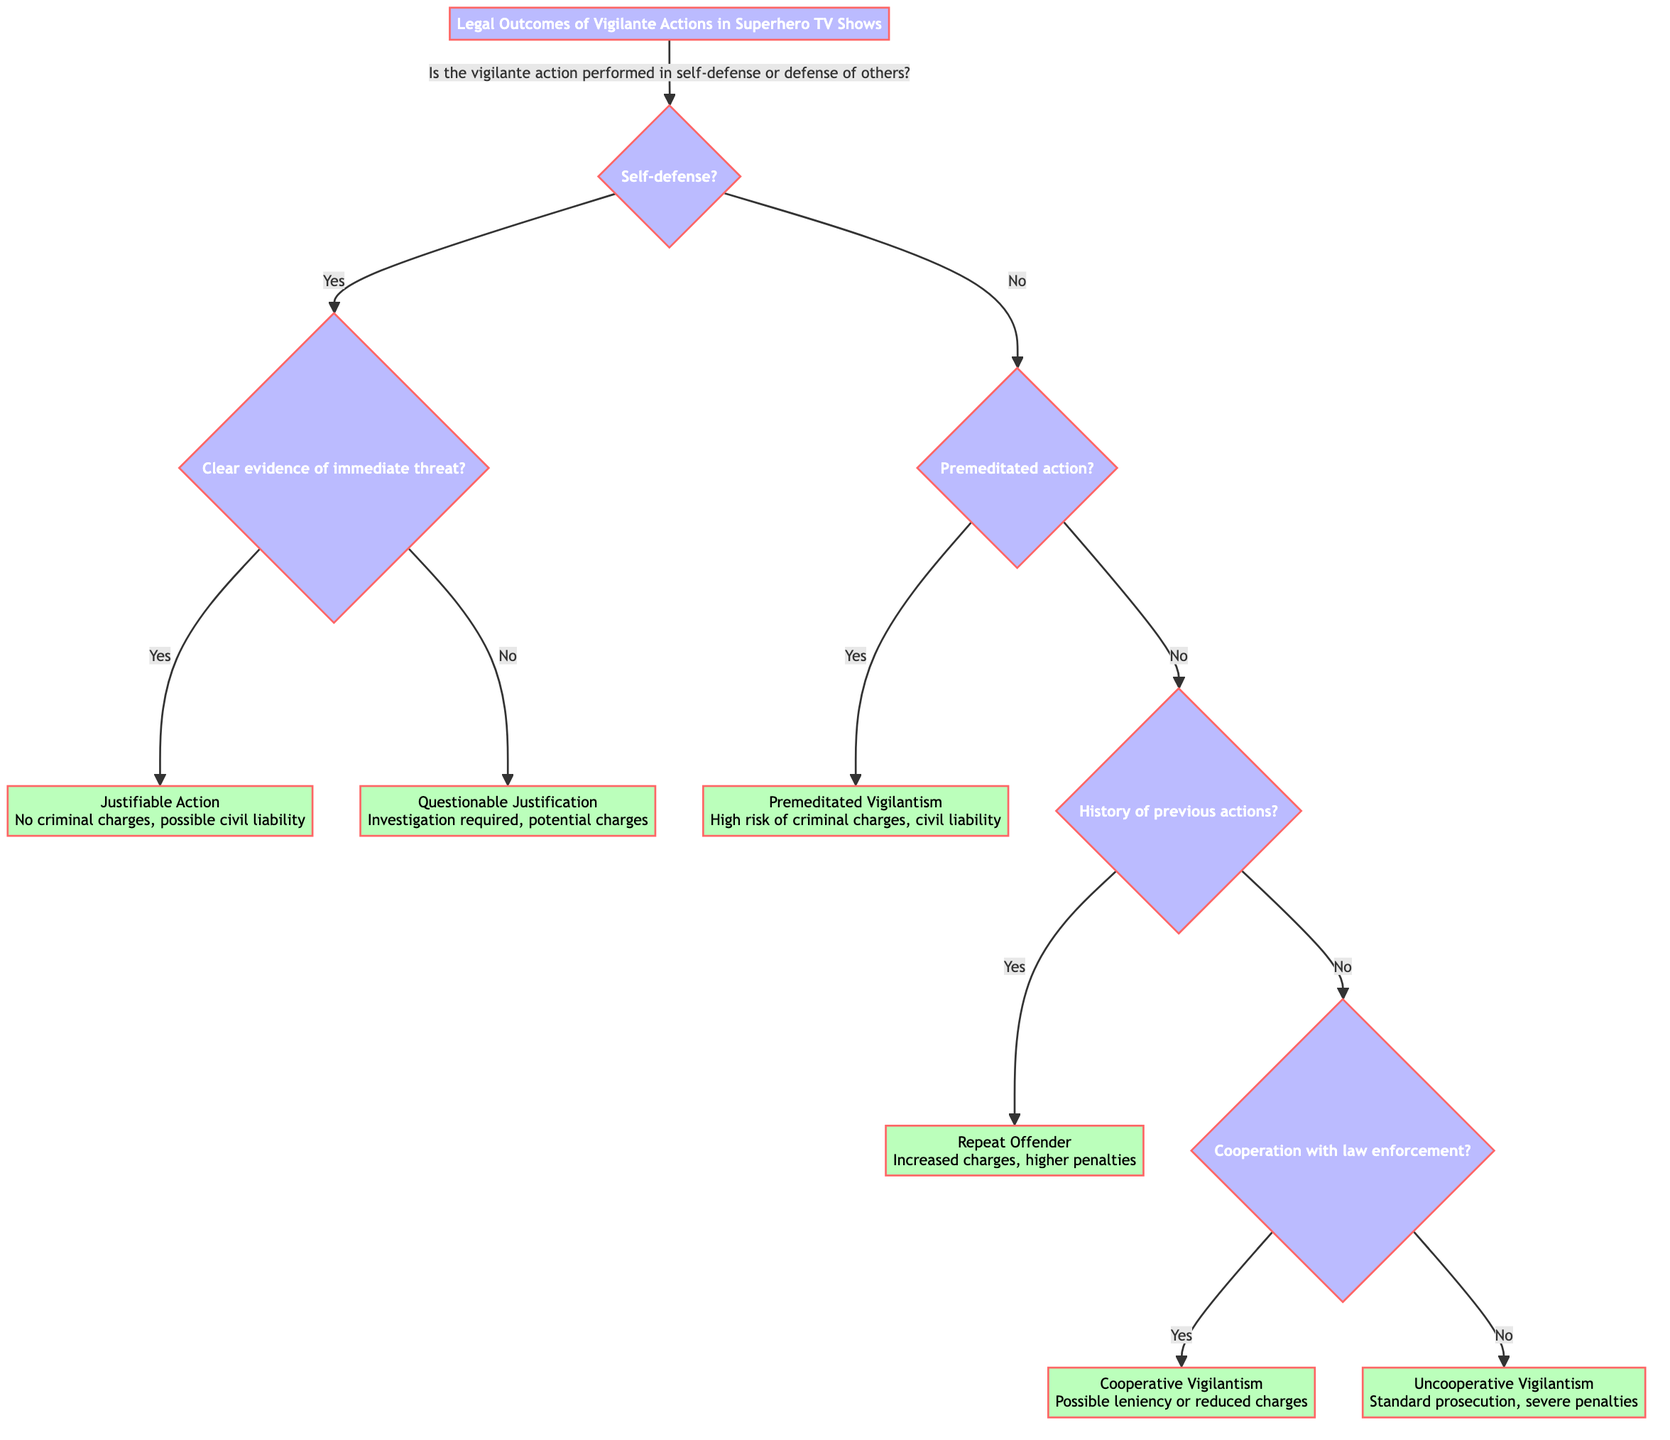Is the first decision about self-defense? Yes, the first decision node specifically asks if the vigilante action is performed in self-defense or defense of others.
Answer: Yes What is the outcome if there is clear evidence of an immediate threat? If there is clear evidence of an immediate threat, the next outcome node indicates that the action is considered "Justifiable Action," with no criminal charges and possible civil liability.
Answer: Justifiable Action How many outcomes follow the decision of premeditation? Following the decision of premeditated action, there are two possible outcomes: "Premeditated Vigilantism" and the other branches regarding the history of previous actions.
Answer: Two What happens if a vigilante has a history of previous actions? If there is a history of previous vigilante actions, the outcome is classified as "Repeat Offender," which indicates increased criminal charges and the possibility of higher penalties.
Answer: Repeat Offender What is the legal response for "Cooperative Vigilantism"? The legal response outlined for "Cooperative Vigilantism" describes the possibility of leniency or reduced charges based on jurisdiction and circumstances surrounding the case.
Answer: Possible leniency or reduced charges What is the outcome if the vigilante action is uncooperative? According to the diagram, if the vigilante action is categorized as uncooperative, the outcome noted is "Uncooperative Vigilantism," subjected to standard prosecution procedures and the potential for severe penalties.
Answer: Uncooperative Vigilantism Is there a decision regarding cooperation with law enforcement? Yes, there is a specific decision node that asks whether there was cooperation with law enforcement, which determines the outcome path taken next.
Answer: Yes What is the outcome for an action deemed as "Questionable Justification"? The outcome for "Questionable Justification" indicates that an investigation is required, which may result in potential criminal charges or civil liability.
Answer: Questionable Justification What are the criminal implications for premeditated vigilantism? The implications state that premeditated vigilantism carries a high risk of criminal charges, such as assault or murder, along with potential civil liability.
Answer: High risk of criminal charges 